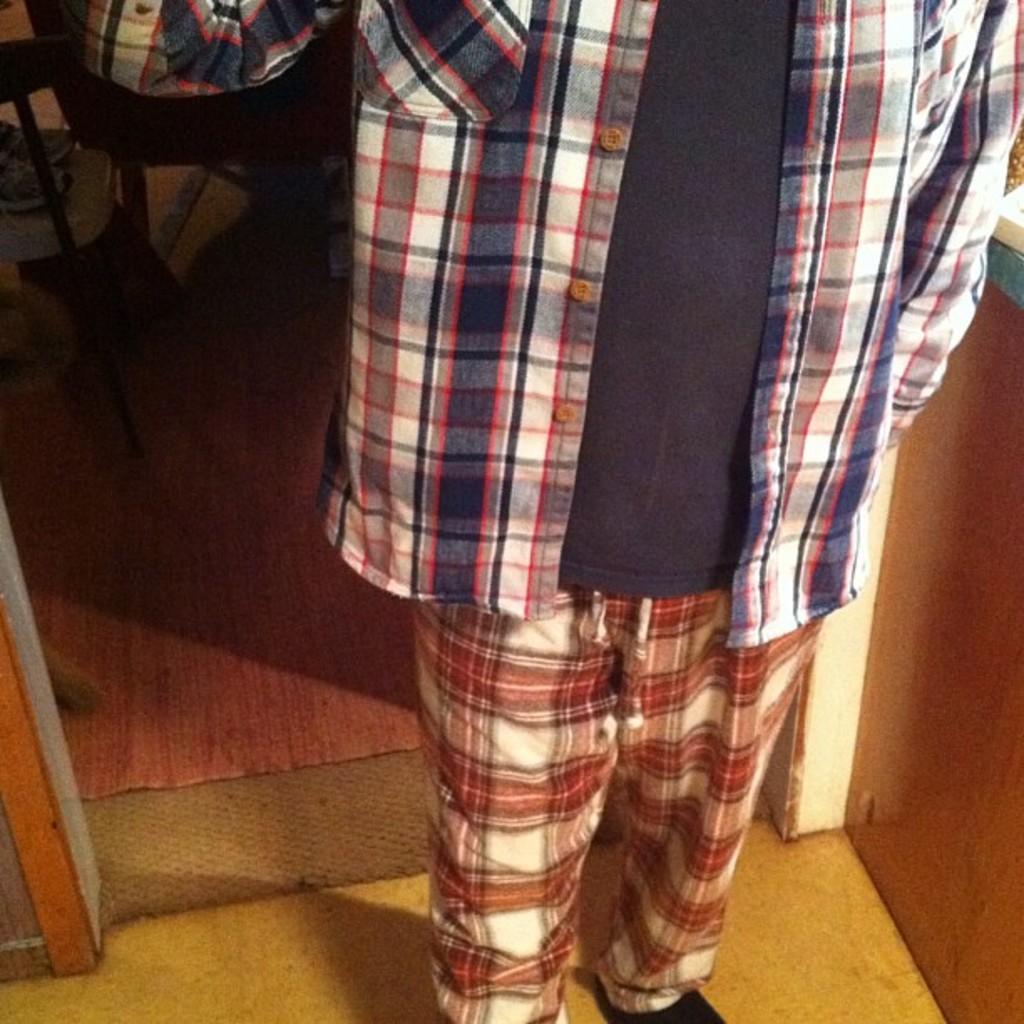Please provide a concise description of this image. This picture shows an incomplete picture of a person. 